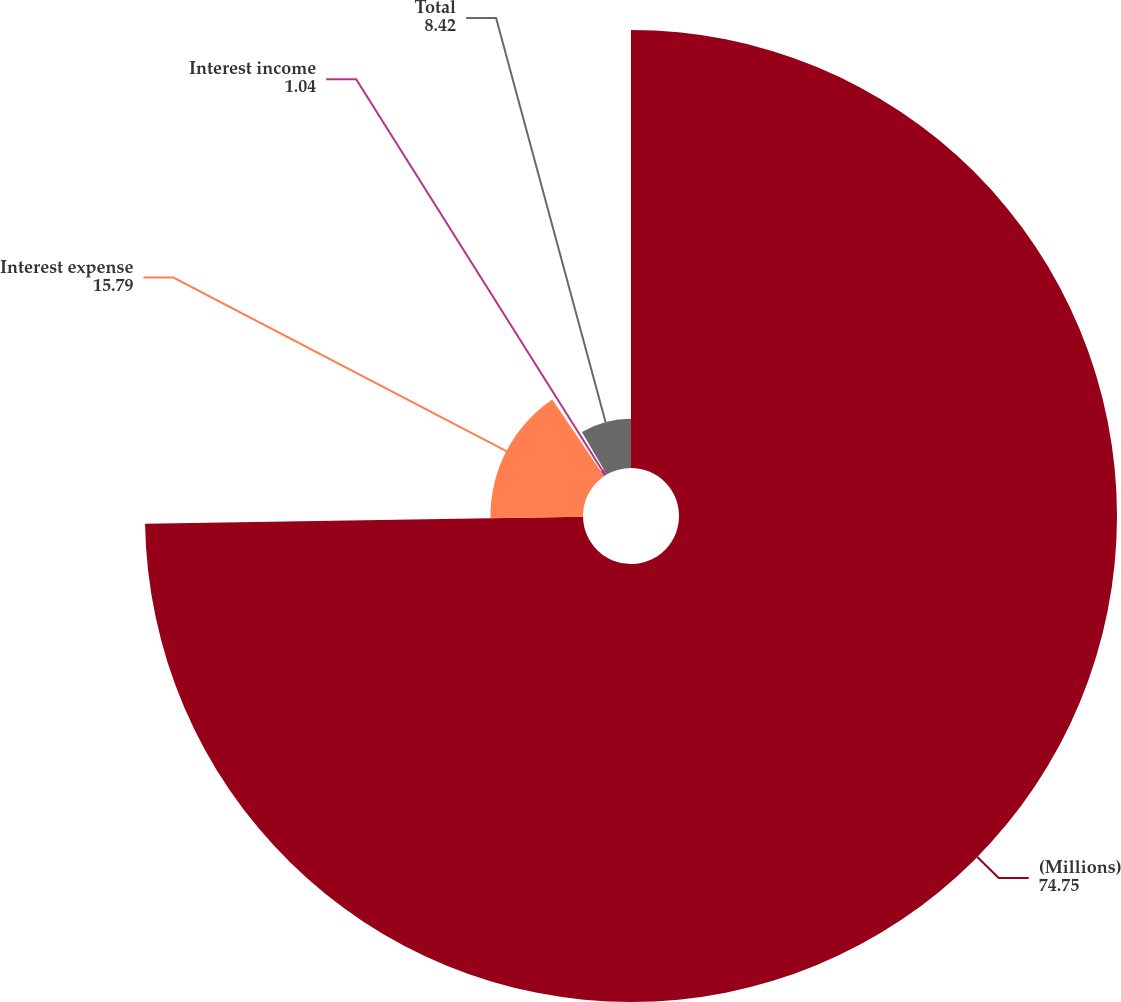Convert chart. <chart><loc_0><loc_0><loc_500><loc_500><pie_chart><fcel>(Millions)<fcel>Interest expense<fcel>Interest income<fcel>Total<nl><fcel>74.75%<fcel>15.79%<fcel>1.04%<fcel>8.42%<nl></chart> 